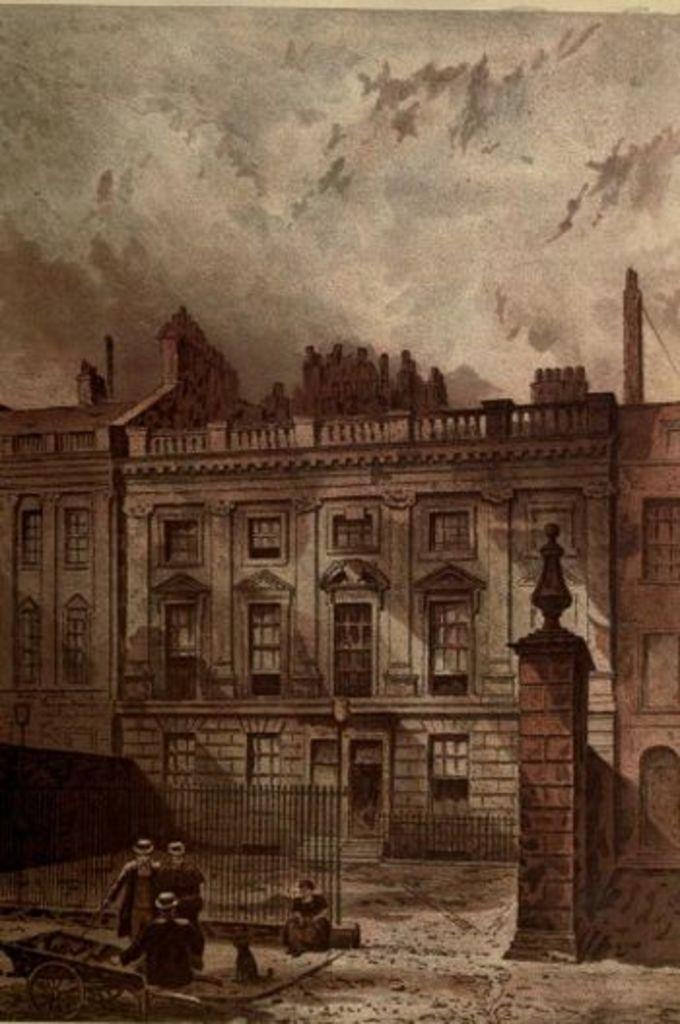Can you describe this image briefly? In this image we can see a picture of a building, a metal railing in front of the building, a pillar and few people on the ground, an animal and a cart beside the person and there are few people standing on the building and sky in the background. 